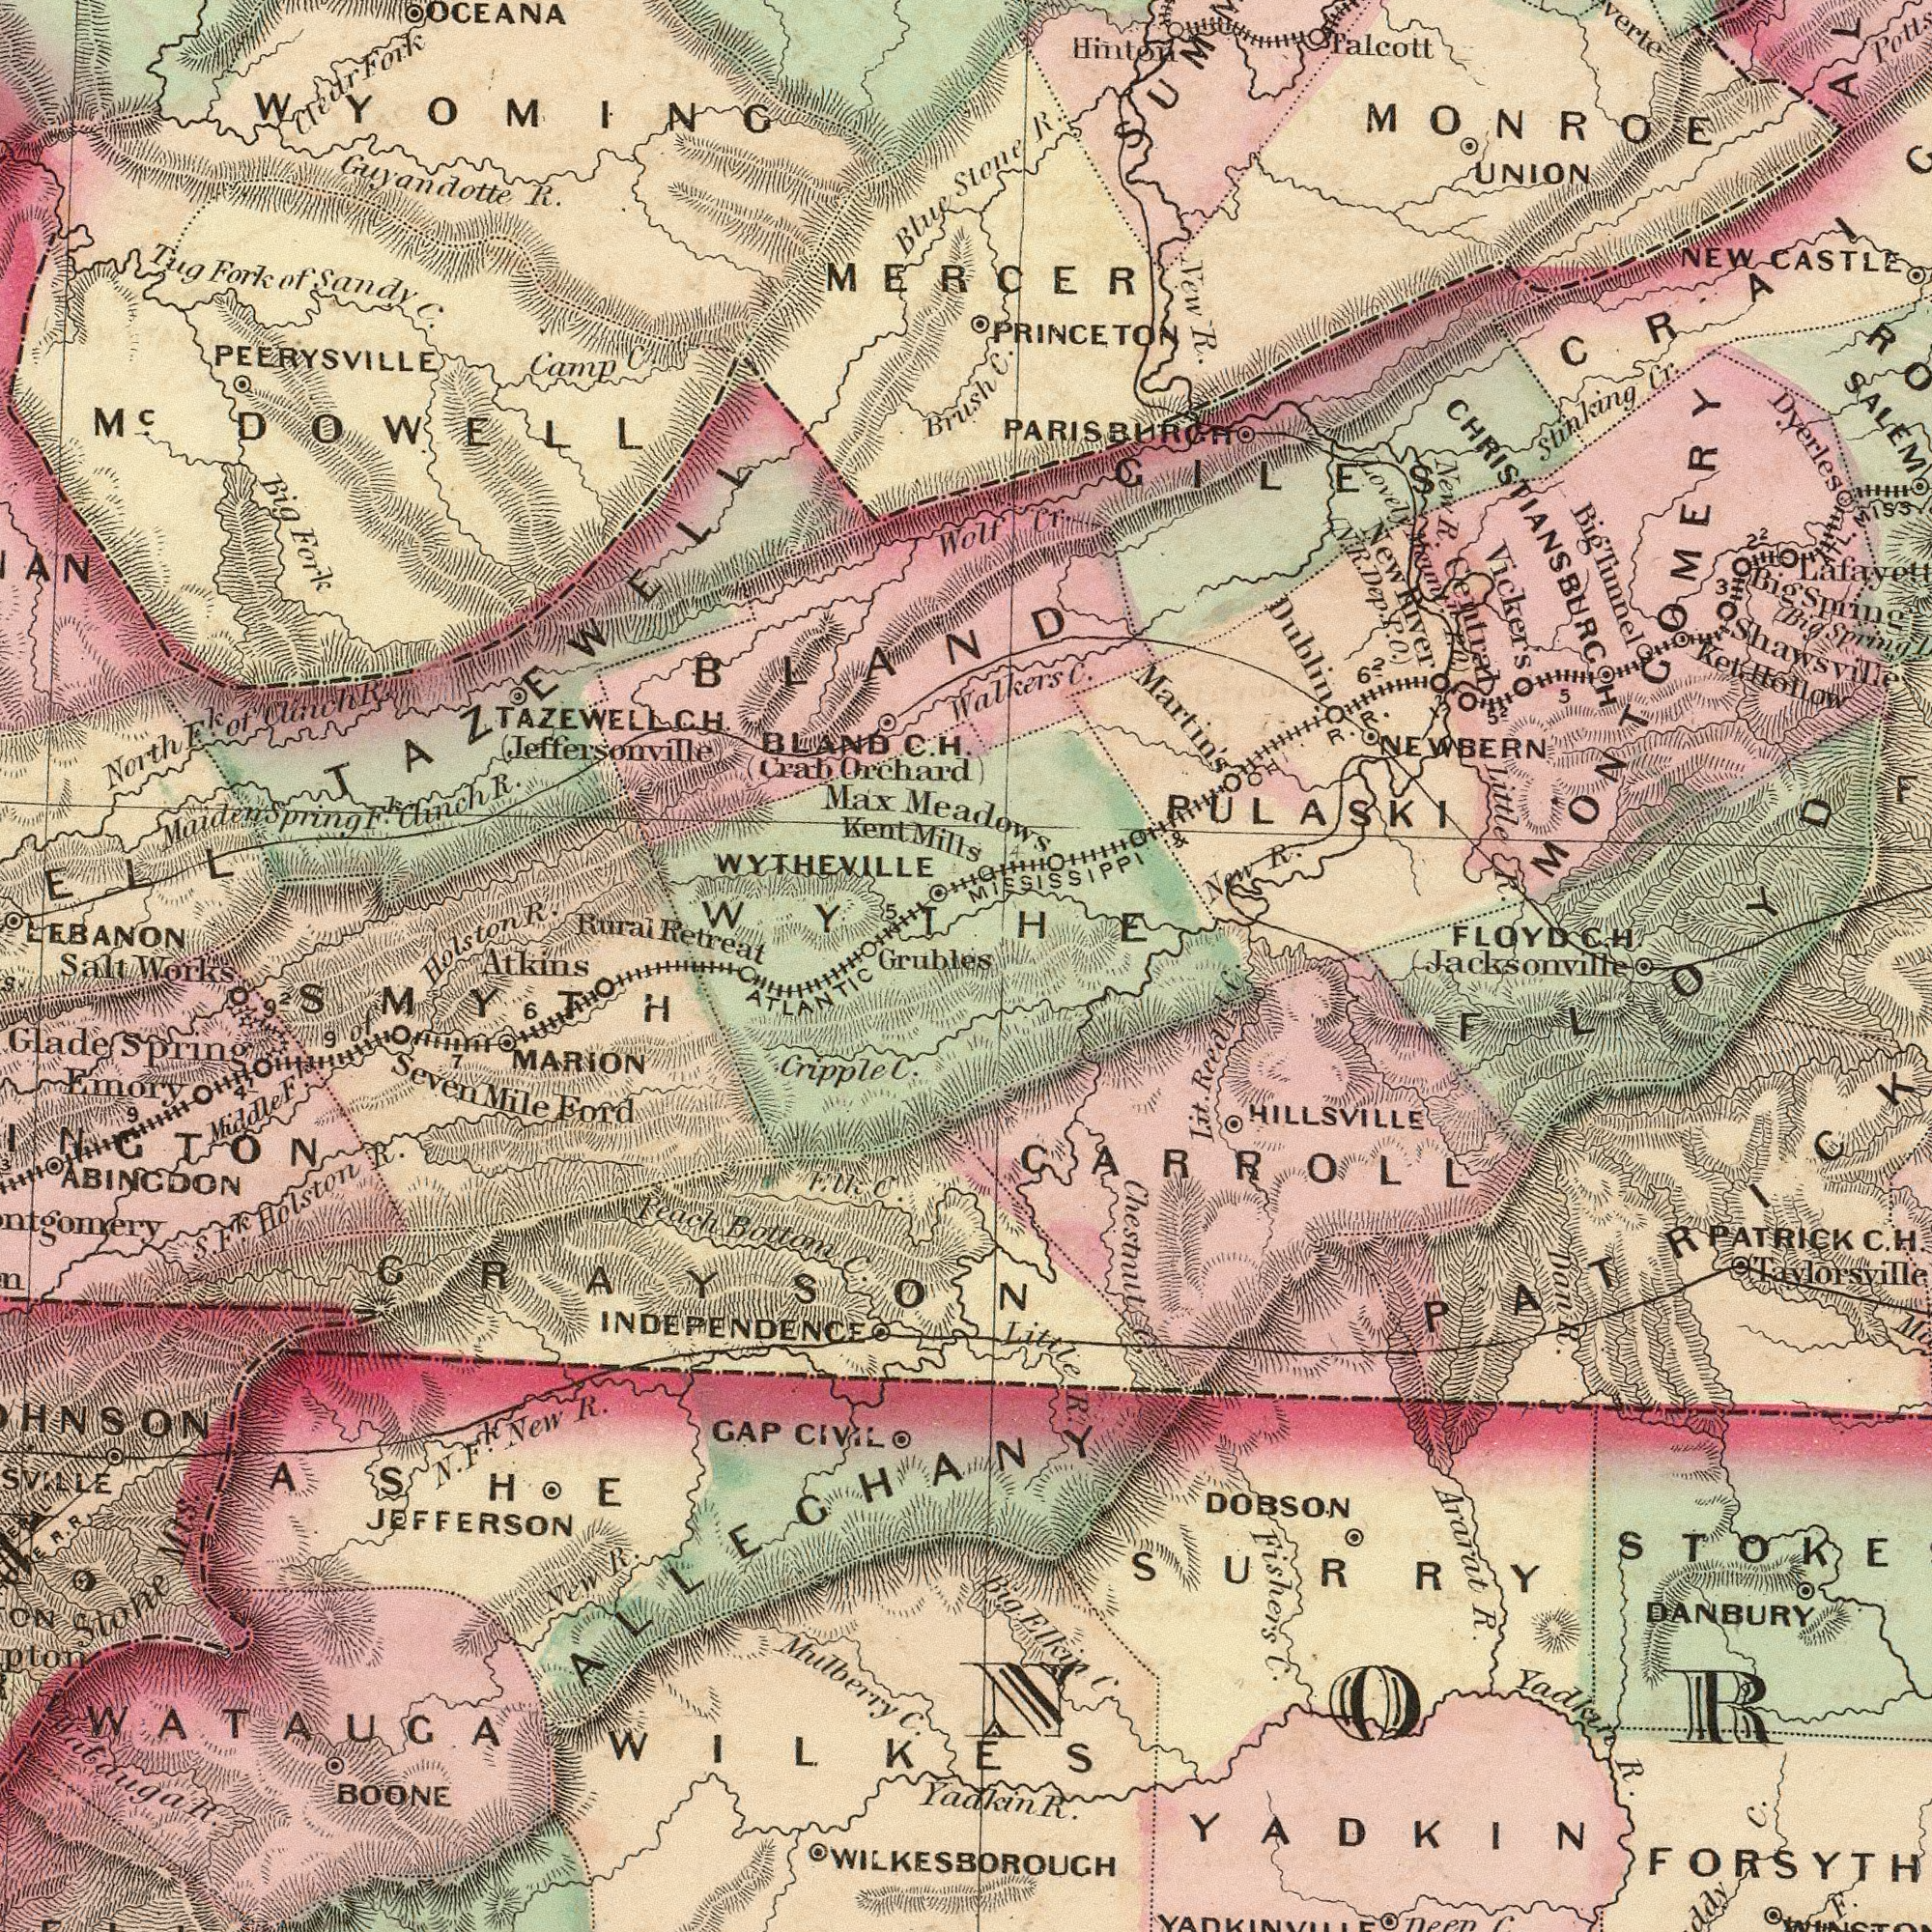What text is shown in the top-left quadrant? PEERYSVILLE WYTHEVILLE Max OCEANA Rural Retreat Guyandotte R. Tug Fork of Sandy C. LEBANON M<sup>c</sup>. DOWELL MaidenSpring F. Clinch R. WYOMING Crab Orchard Camp C. Jeffersonville Holston R. North Fk of Clinch R. Kent Mills TAZEWELLCH. BLAND C. H. Blue Brush Clear Fork Big Eork TAZEWELL BLAND WYTHE 5 Grubles What text is visible in the lower-left corner? MiddleF F. of JEFFERSON MARION Peach Bottom C. BOONE Stone S. Fk . Holston R. SevenMile Ford Emory Mts New R. Mulberry C. GAP CIVILO N. Fk. New R. ATLANTIC SMYTH Glade Spring GRAYSON WATAUGA WILKES INDEPENDENCE 6 INGTON Watauga R. F. lk C. ASHE ABINGDON Cripple C. 9 9 7 3 Atkins 92 Salt Works ALLECHANY 41 What text appears in the bottom-right area of the image? WILKESBOROUGH Chesmut C. Ararat R. HILLSVILLE DANBURY NOR FORSYTH C. Fishers C. F. DOBSON SURRY YADKIN PATRICK C. H. Lit. Reedl C. YadkIn R. Dan R. Yadkin R. Big Elkin C. Little R. CARROLL Jacksonville What text is visible in the upper-right corner? MEADOWS UNION SALEM Stinking Cr. Vickers FLOYD C. H. Little R. New R. NEWBERN PULASKI MONROE NEW CASTLE Palcott PARISBURGH Stone R. Shawsville Walkers C. Big Tumel Ket. Hollow Central New R. Wolf Cr ATL. MISS Martin's Dyerles C. MIESISSIPPI & R. R. New R. Hinton PRINCETON Lovely Mount. P. O. GILES Dublin CHRISTIANSBURGH 5 5 22 MERCER MONTGOMERY 62 New River N. R. Dep. P. O. 3 52 12 Big Spring Big Spring 